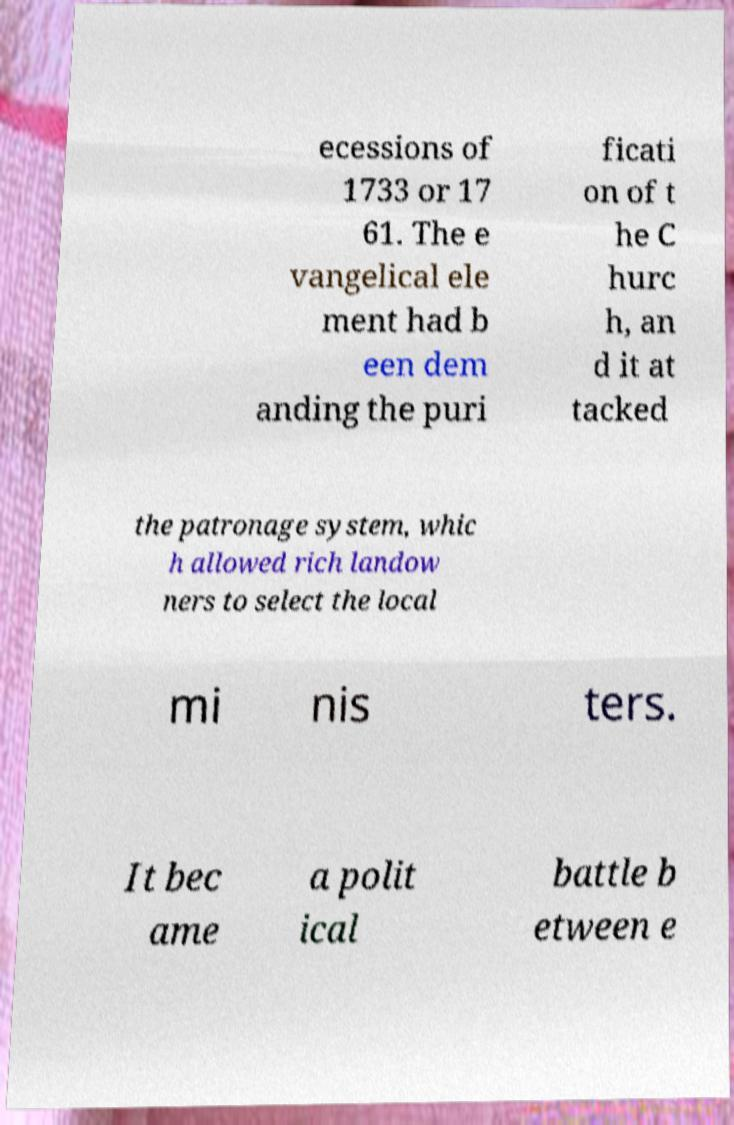Could you assist in decoding the text presented in this image and type it out clearly? ecessions of 1733 or 17 61. The e vangelical ele ment had b een dem anding the puri ficati on of t he C hurc h, an d it at tacked the patronage system, whic h allowed rich landow ners to select the local mi nis ters. It bec ame a polit ical battle b etween e 